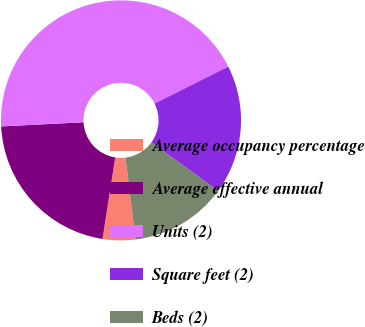Convert chart to OTSL. <chart><loc_0><loc_0><loc_500><loc_500><pie_chart><fcel>Average occupancy percentage<fcel>Average effective annual<fcel>Units (2)<fcel>Square feet (2)<fcel>Beds (2)<nl><fcel>4.39%<fcel>21.73%<fcel>43.41%<fcel>17.4%<fcel>13.06%<nl></chart> 